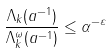Convert formula to latex. <formula><loc_0><loc_0><loc_500><loc_500>\frac { \Lambda _ { k } ( a ^ { - 1 } ) } { \Lambda _ { k } ^ { \omega } ( a ^ { - 1 } ) } \leq \alpha ^ { - \varepsilon }</formula> 